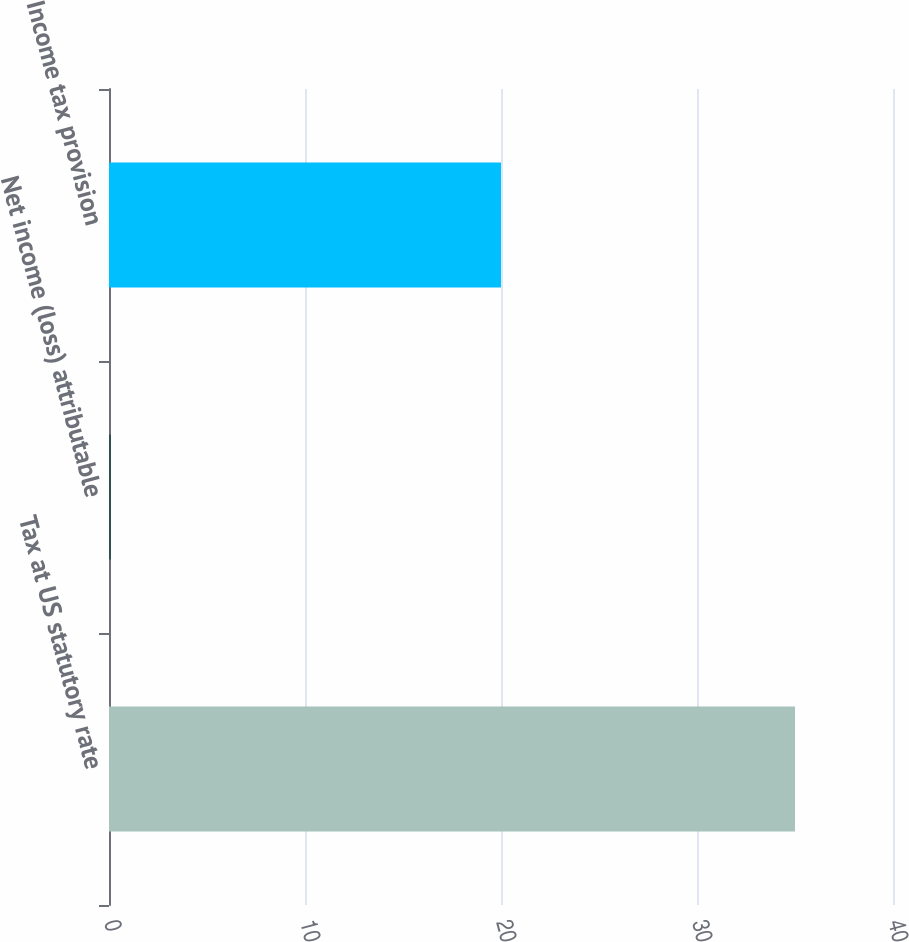Convert chart to OTSL. <chart><loc_0><loc_0><loc_500><loc_500><bar_chart><fcel>Tax at US statutory rate<fcel>Net income (loss) attributable<fcel>Income tax provision<nl><fcel>35<fcel>0.1<fcel>20<nl></chart> 